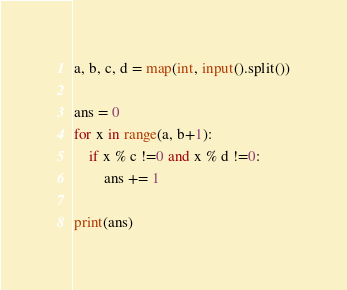Convert code to text. <code><loc_0><loc_0><loc_500><loc_500><_Python_>a, b, c, d = map(int, input().split())

ans = 0
for x in range(a, b+1):
    if x % c !=0 and x % d !=0:
        ans += 1

print(ans)
</code> 